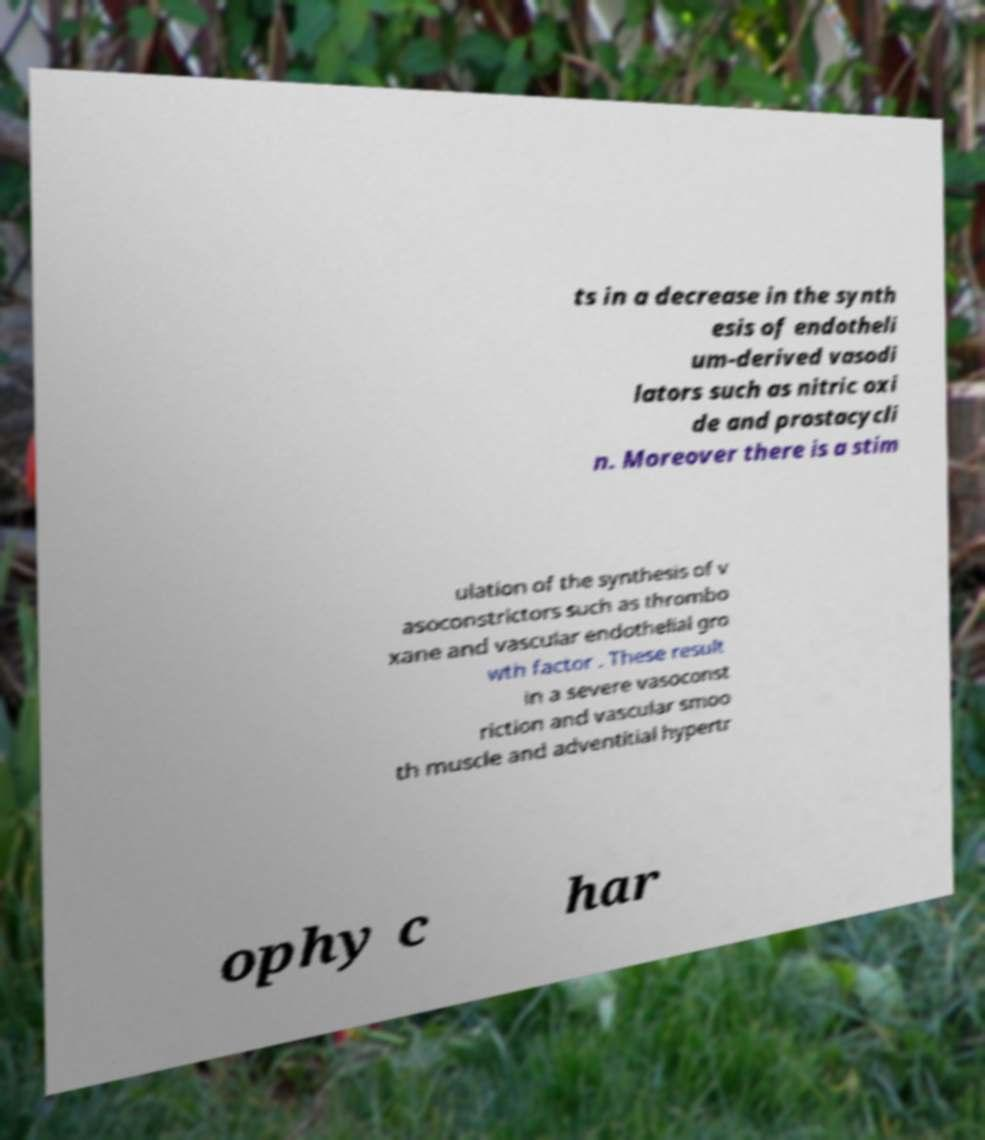Could you extract and type out the text from this image? ts in a decrease in the synth esis of endotheli um-derived vasodi lators such as nitric oxi de and prostacycli n. Moreover there is a stim ulation of the synthesis of v asoconstrictors such as thrombo xane and vascular endothelial gro wth factor . These result in a severe vasoconst riction and vascular smoo th muscle and adventitial hypertr ophy c har 